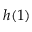<formula> <loc_0><loc_0><loc_500><loc_500>h ( 1 )</formula> 